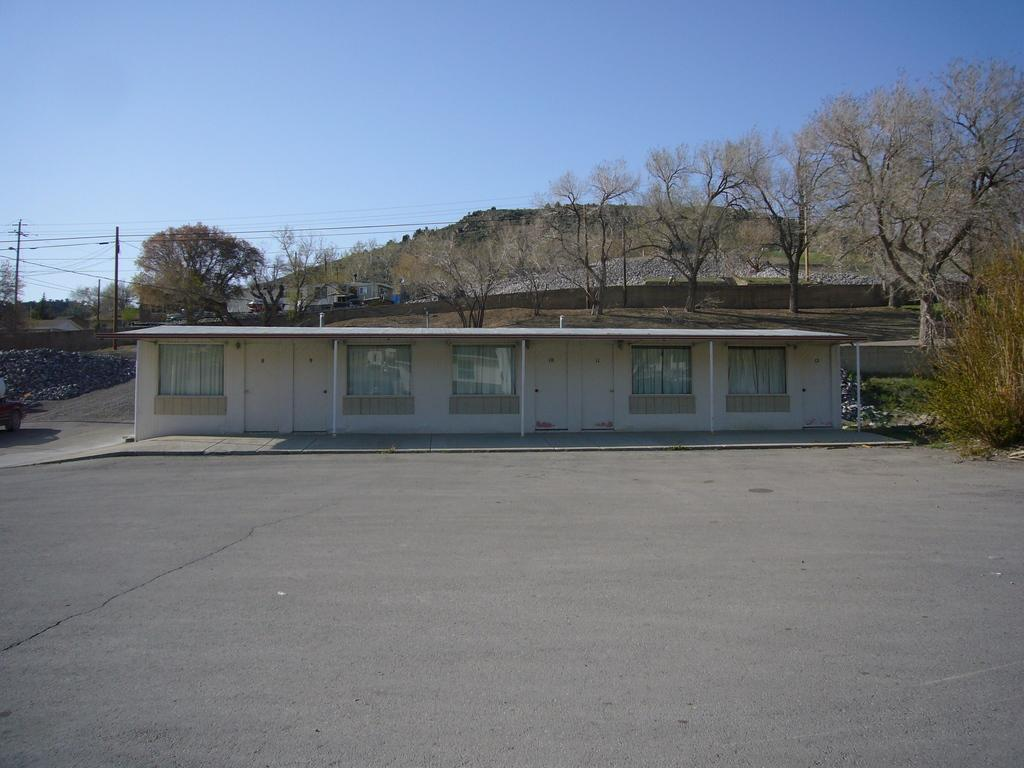Where was the image taken? The image was clicked outside. What can be seen in the middle of the image? There are trees and a house in the middle of the image. What features can be observed on the house? The house has windows. What is present on the left side of the image? There are poles on the left side of the image. What is visible at the top of the image? The sky is visible at the top of the image. How many bikes are parked in the drawer in the image? There are no bikes or drawers present in the image. What type of tank can be seen near the house in the image? There is no tank present near the house in the image. 